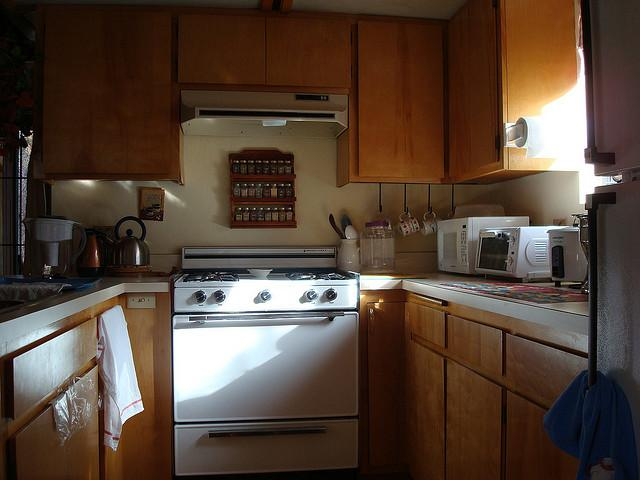What is the shorter rectangular appliance called?

Choices:
A) air conditioner
B) toaster oven
C) microwave
D) food dehydrator microwave 